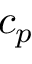Convert formula to latex. <formula><loc_0><loc_0><loc_500><loc_500>c _ { p }</formula> 